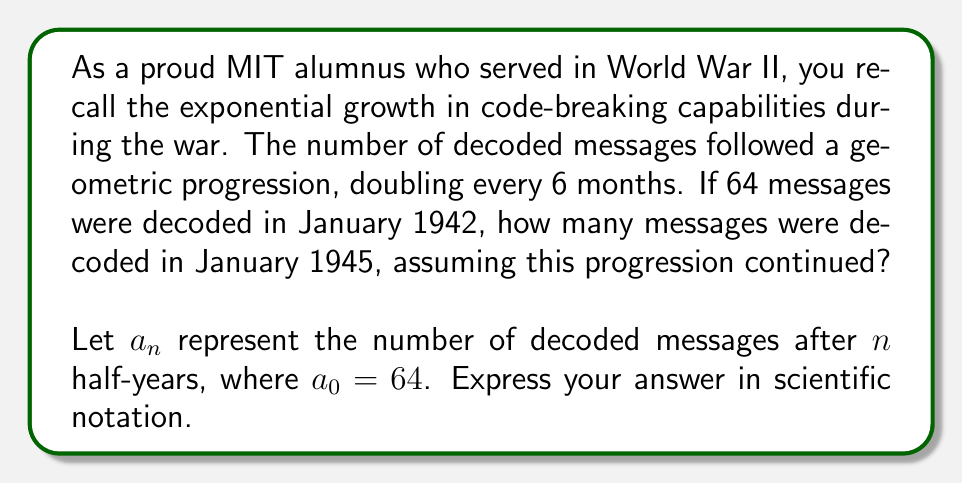Teach me how to tackle this problem. To solve this problem, we'll use the formula for geometric sequences:

$$a_n = a_0 \cdot r^n$$

Where:
$a_n$ is the nth term of the sequence
$a_0$ is the initial term (64 in this case)
$r$ is the common ratio (2 in this case, as the number doubles every 6 months)
$n$ is the number of terms minus one

First, let's calculate how many 6-month periods are between January 1942 and January 1945:

1942 to 1943: 2 periods
1943 to 1944: 2 periods
1944 to 1945: 2 periods

Total: 6 periods

So, $n = 6$

Now, let's plug these values into our formula:

$$a_6 = 64 \cdot 2^6$$

$$a_6 = 64 \cdot 64 = 4096$$

Therefore, in January 1945, 4096 messages were being decoded.

To express this in scientific notation:

$$4096 = 4.096 \times 10^3$$
Answer: $4.096 \times 10^3$ messages 